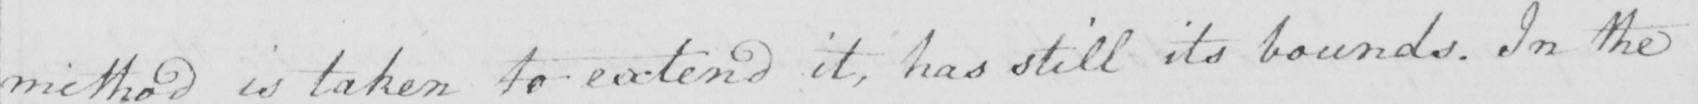What does this handwritten line say? method is taken to extend it , has still its bounds . In the 